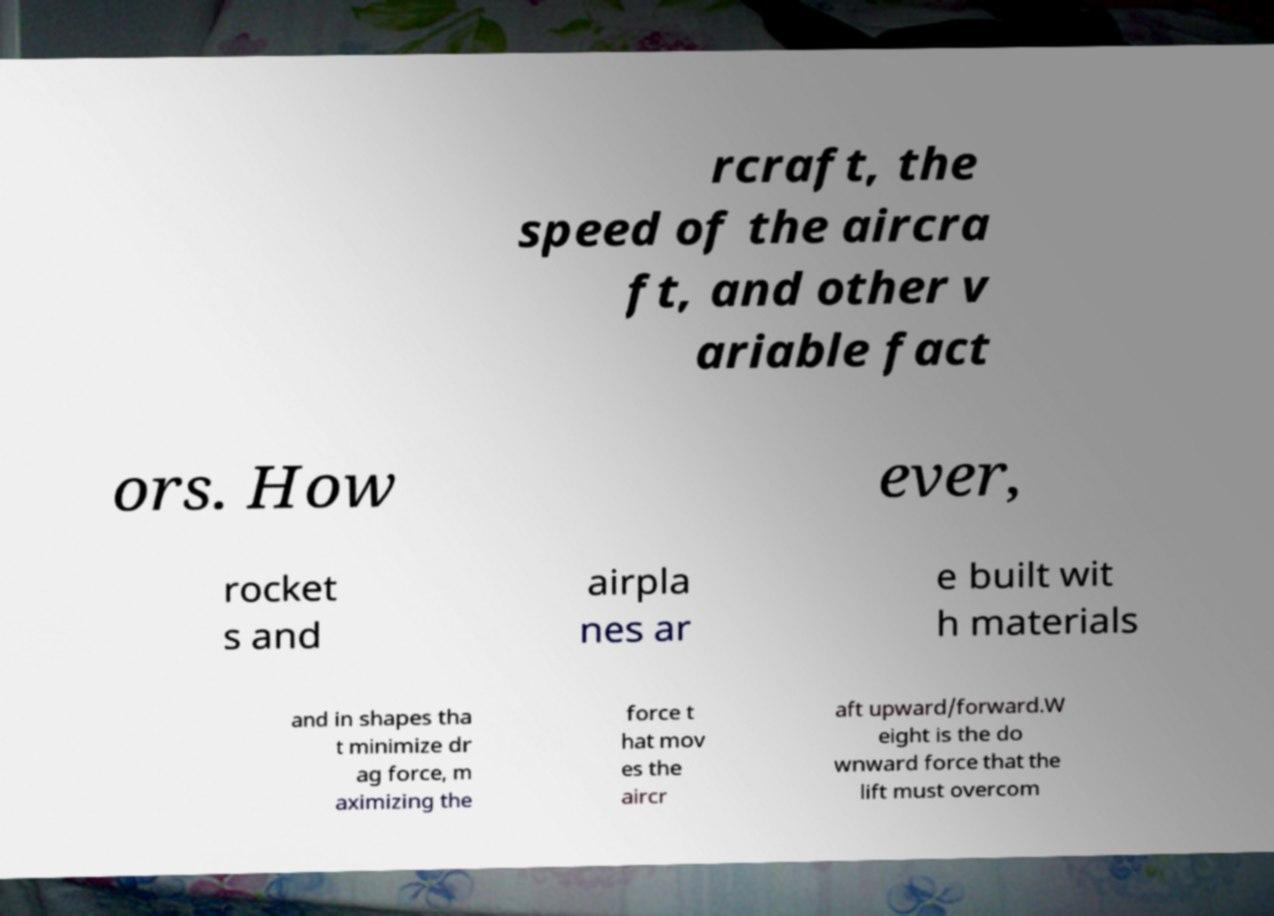There's text embedded in this image that I need extracted. Can you transcribe it verbatim? rcraft, the speed of the aircra ft, and other v ariable fact ors. How ever, rocket s and airpla nes ar e built wit h materials and in shapes tha t minimize dr ag force, m aximizing the force t hat mov es the aircr aft upward/forward.W eight is the do wnward force that the lift must overcom 